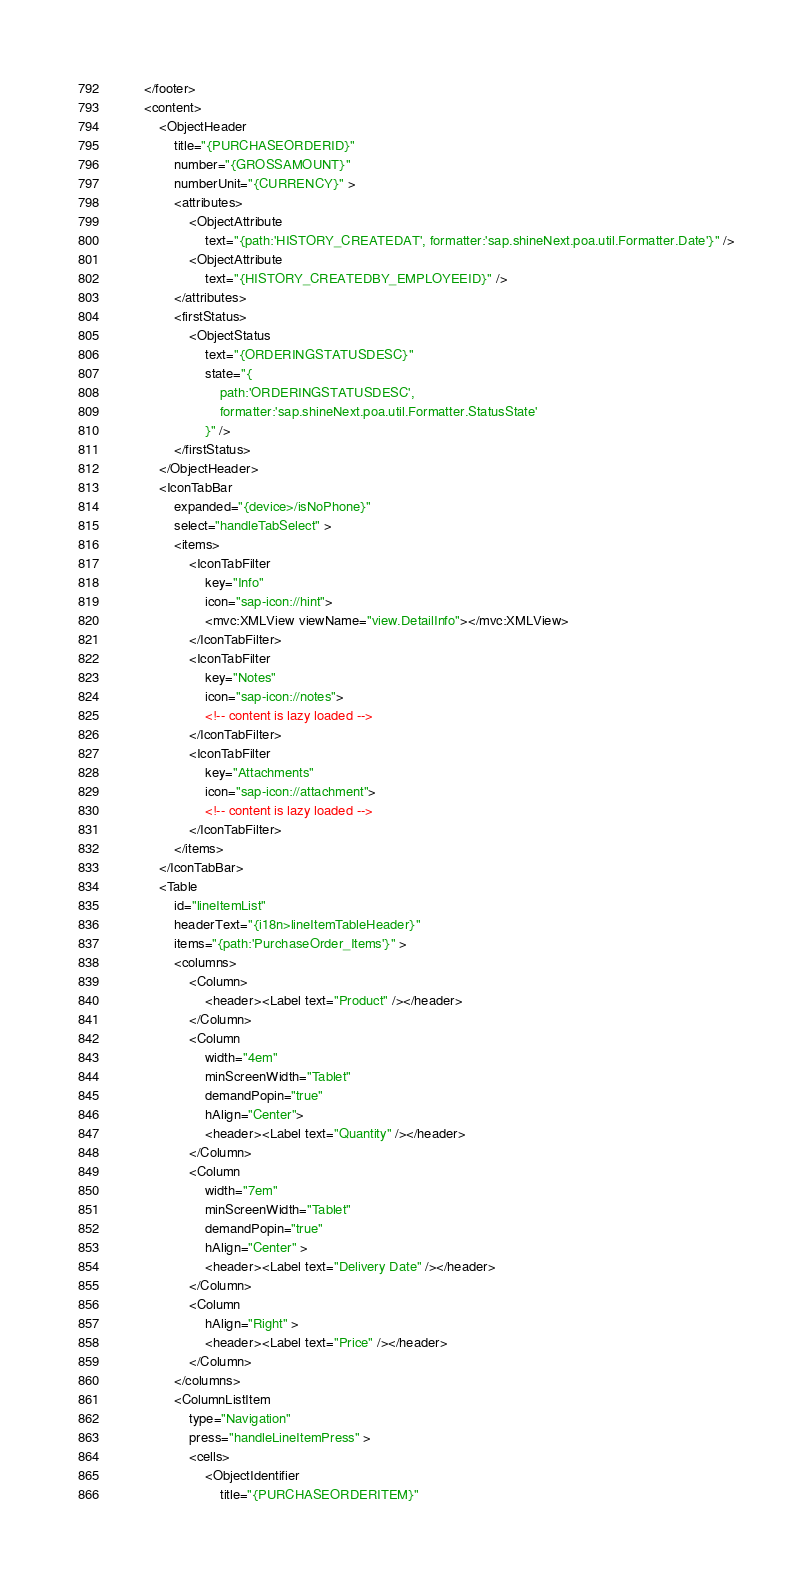Convert code to text. <code><loc_0><loc_0><loc_500><loc_500><_XML_>		</footer>
		<content>
			<ObjectHeader
				title="{PURCHASEORDERID}"
				number="{GROSSAMOUNT}"
				numberUnit="{CURRENCY}" >
				<attributes>
					<ObjectAttribute
						text="{path:'HISTORY_CREATEDAT', formatter:'sap.shineNext.poa.util.Formatter.Date'}" />
					<ObjectAttribute
						text="{HISTORY_CREATEDBY_EMPLOYEEID}" />
				</attributes>
				<firstStatus>
					<ObjectStatus
						text="{ORDERINGSTATUSDESC}"
						state="{
							path:'ORDERINGSTATUSDESC',
							formatter:'sap.shineNext.poa.util.Formatter.StatusState'
						}" />
				</firstStatus>
			</ObjectHeader>
			<IconTabBar
				expanded="{device>/isNoPhone}"
				select="handleTabSelect" >
				<items>
					<IconTabFilter
						key="Info"
						icon="sap-icon://hint">
						<mvc:XMLView viewName="view.DetailInfo"></mvc:XMLView>
					</IconTabFilter>
					<IconTabFilter
						key="Notes"
						icon="sap-icon://notes">
						<!-- content is lazy loaded -->
					</IconTabFilter>
					<IconTabFilter
						key="Attachments"
						icon="sap-icon://attachment">
						<!-- content is lazy loaded -->
					</IconTabFilter>
				</items>
			</IconTabBar>
			<Table
				id="lineItemList"
				headerText="{i18n>lineItemTableHeader}"
				items="{path:'PurchaseOrder_Items'}" >
				<columns>
					<Column>
						<header><Label text="Product" /></header>
					</Column>
					<Column
						width="4em"
						minScreenWidth="Tablet"
						demandPopin="true"
						hAlign="Center">
						<header><Label text="Quantity" /></header>
					</Column>
					<Column
						width="7em"
						minScreenWidth="Tablet"
						demandPopin="true"
						hAlign="Center" >
						<header><Label text="Delivery Date" /></header>
					</Column>
					<Column
						hAlign="Right" >
						<header><Label text="Price" /></header>
					</Column>
				</columns>
				<ColumnListItem
					type="Navigation"
					press="handleLineItemPress" >
					<cells>
						<ObjectIdentifier
							title="{PURCHASEORDERITEM}"</code> 